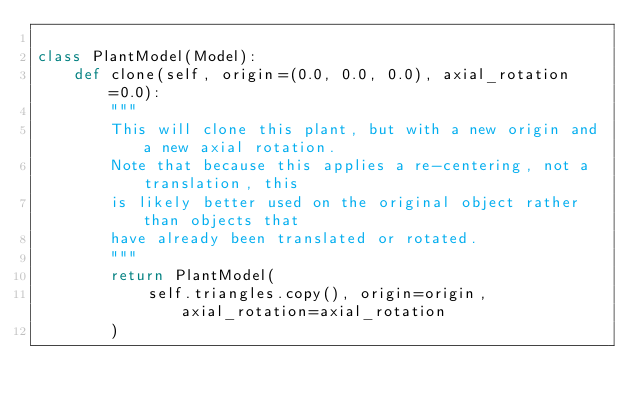Convert code to text. <code><loc_0><loc_0><loc_500><loc_500><_Python_>
class PlantModel(Model):
    def clone(self, origin=(0.0, 0.0, 0.0), axial_rotation=0.0):
        """
        This will clone this plant, but with a new origin and a new axial rotation.
        Note that because this applies a re-centering, not a translation, this
        is likely better used on the original object rather than objects that
        have already been translated or rotated.
        """
        return PlantModel(
            self.triangles.copy(), origin=origin, axial_rotation=axial_rotation
        )
</code> 